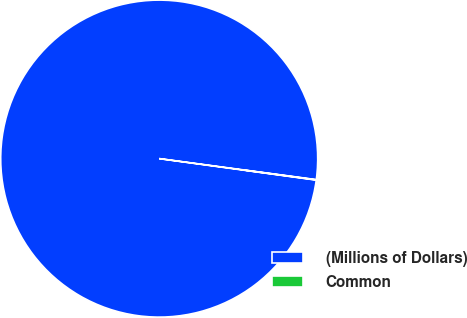<chart> <loc_0><loc_0><loc_500><loc_500><pie_chart><fcel>(Millions of Dollars)<fcel>Common<nl><fcel>99.95%<fcel>0.05%<nl></chart> 